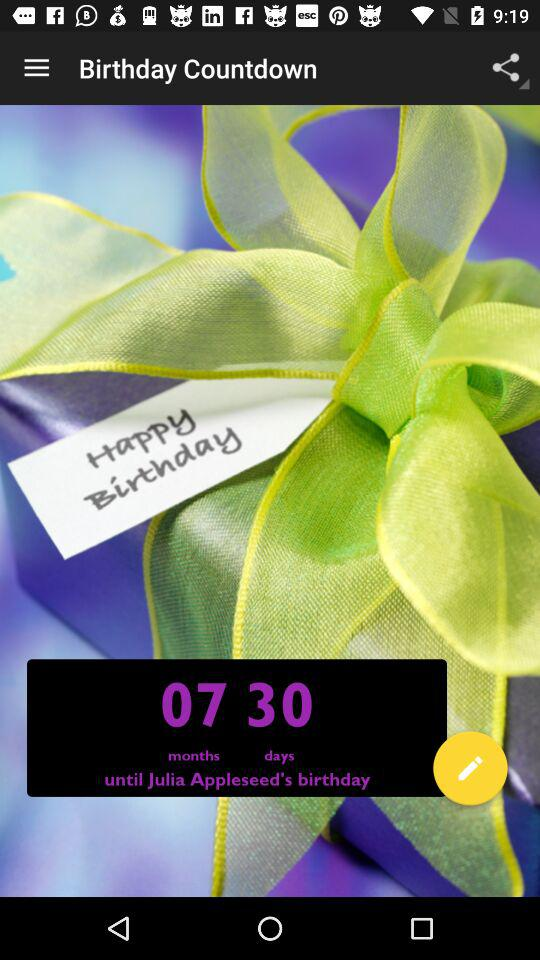Whose birthday is it? It is the birthday of Julia Appleseed. 